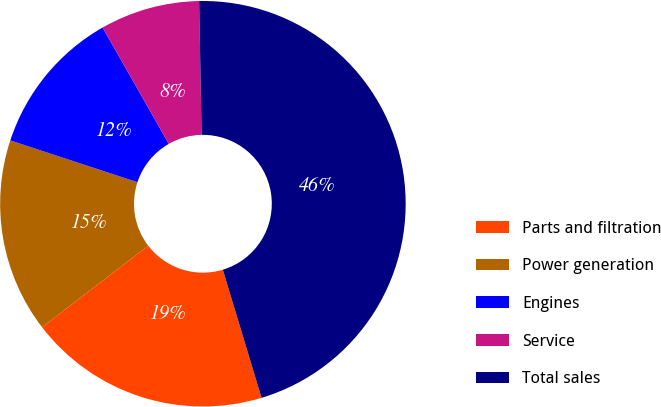Convert chart to OTSL. <chart><loc_0><loc_0><loc_500><loc_500><pie_chart><fcel>Parts and filtration<fcel>Power generation<fcel>Engines<fcel>Service<fcel>Total sales<nl><fcel>19.25%<fcel>15.48%<fcel>11.71%<fcel>7.94%<fcel>45.63%<nl></chart> 